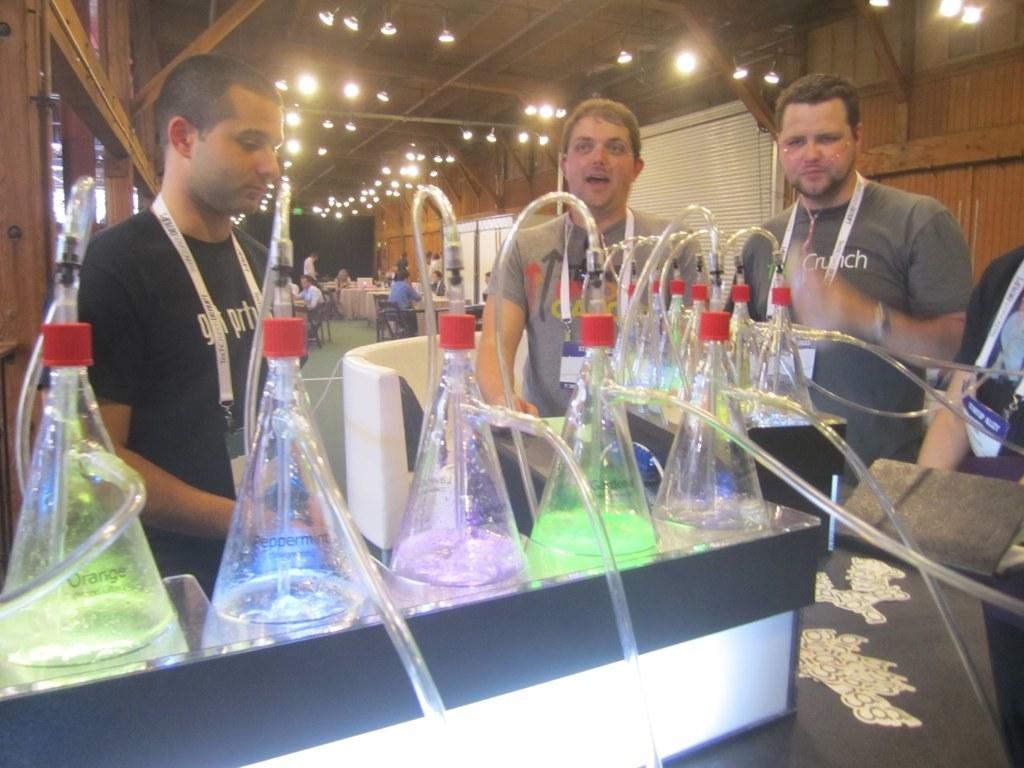How many people are present in the image? There are four persons in the image. What objects are in front of the four persons? There are bottles in front of the four persons. Can you describe the setting in the background of the image? There is a group of people sitting on chairs in the background of the image, and lights are visible. What type of border can be seen around the image? There is no border visible around the image. What observation can be made about the chairs in the background? The chairs are not the focus of the image, but they are part of the background setting where a group of people is sitting. 